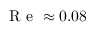Convert formula to latex. <formula><loc_0><loc_0><loc_500><loc_500>R e \approx 0 . 0 8</formula> 